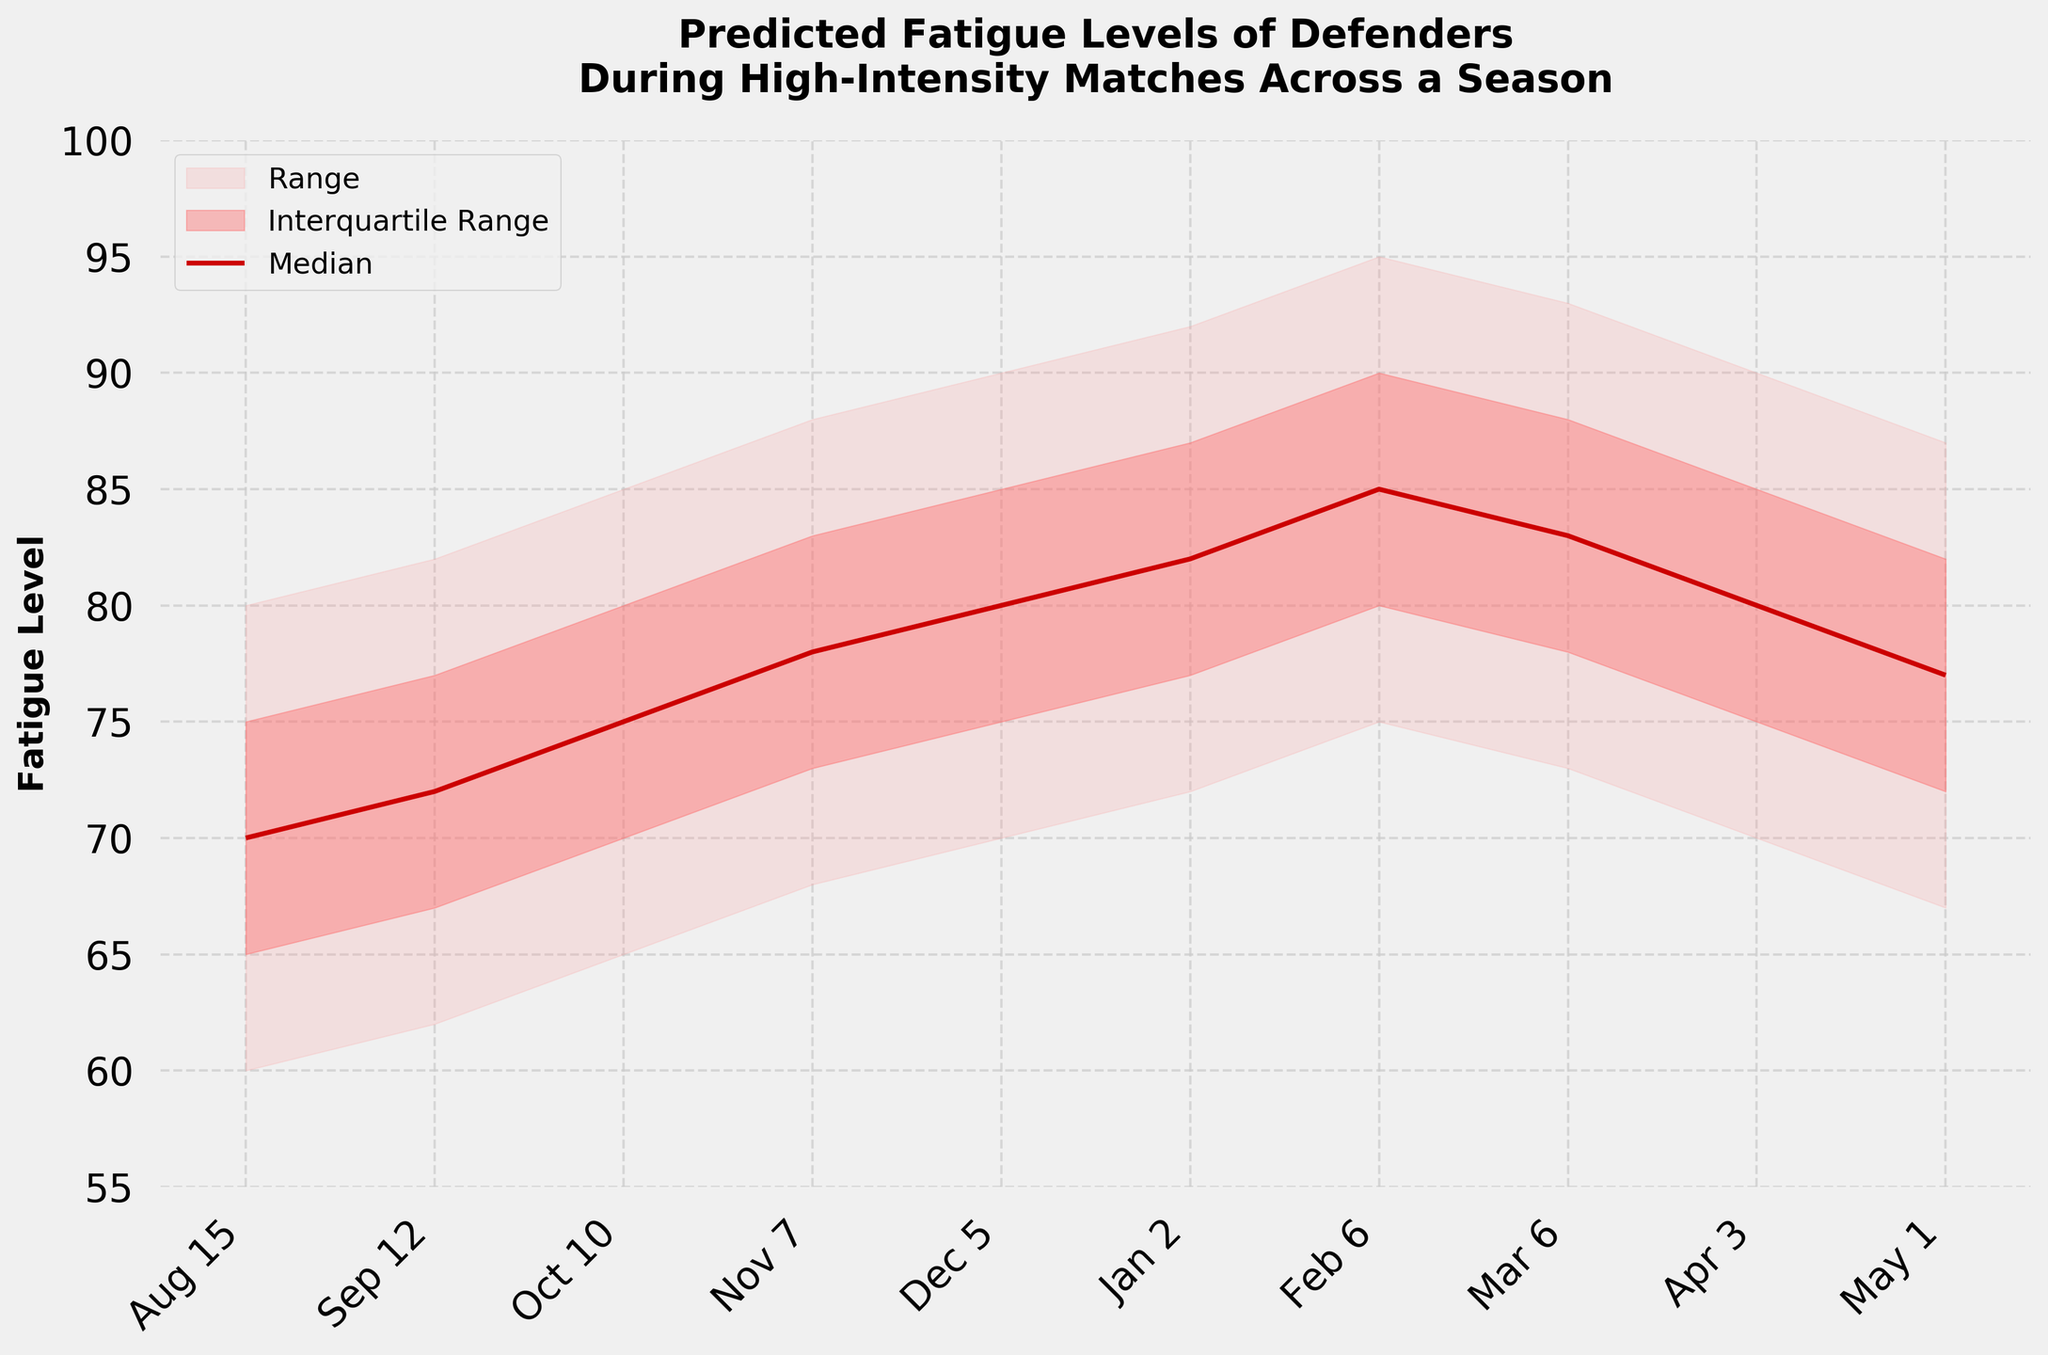What is the title of the chart? The title is usually located at the top of the chart, written in bold and larger font. For this figure, it reads: "Predicted Fatigue Levels of Defenders During High-Intensity Matches Across a Season."
Answer: Predicted Fatigue Levels of Defenders During High-Intensity Matches Across a Season What does the vertical axis represent? The vertical axis represents the metric being measured in the chart. Here, it is labeled "Fatigue Level," indicating it measures the predicted fatigue levels of the defenders.
Answer: Fatigue Level During which month is the median fatigue level the highest? Look for the data point where the line representing the median value reaches its highest position on the vertical axis. In this case, the highest median value is in February.
Answer: February Which range of fatigue levels does the interquartile range (Q1 to Q3) fall into during October? Observe the shaded area between the Q1 and Q3 values for October. Q1 is 70 and Q3 is 80, so the interquartile range is between 70 and 80.
Answer: 70 to 80 How does the fatigue level trend from August to February? Examine the median line from August to February. The trend shows a gradual increase in the median fatigue level over this period.
Answer: Gradually increases What is the difference between the highest and lowest predicted fatigue levels in December? Identify the "High" and "Low" values for December, which are 90 and 70, respectively. Calculate the difference: 90 - 70 = 20.
Answer: 20 During which month is the variability in fatigue levels the highest, and how can you tell? Look for the month where the range between the "Low" and "High" values is the largest. In this case, February has the widest range (75 to 95), indicating the highest variability.
Answer: February Which months have a median fatigue level of 80? Locate the months where the median line intersects the value 80 on the vertical axis. These months are December and April.
Answer: December and April How does the fatigue level in March compare with the fatigue level in April at the Q1 mark? Compare the Q1 values for March and April. March has a Q1 value of 78, while April has a Q1 value of 75. March's Q1 is higher than April's.
Answer: March's Q1 is higher than April's What pattern do you observe in the median fatigue levels from April to May? Analyze the median line from April to May. The median fatigue level decreases from April (80) to May (77).
Answer: Decreasing pattern 